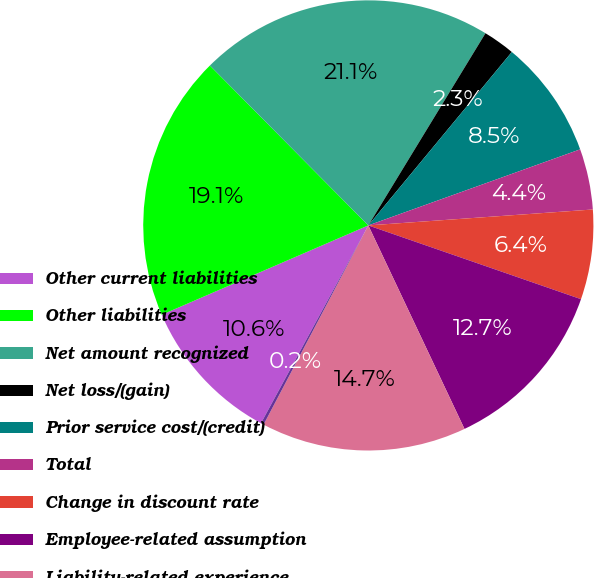Convert chart to OTSL. <chart><loc_0><loc_0><loc_500><loc_500><pie_chart><fcel>Other current liabilities<fcel>Other liabilities<fcel>Net amount recognized<fcel>Net loss/(gain)<fcel>Prior service cost/(credit)<fcel>Total<fcel>Change in discount rate<fcel>Employee-related assumption<fcel>Liability-related experience<fcel>Actual asset return different<nl><fcel>10.59%<fcel>19.07%<fcel>21.14%<fcel>2.29%<fcel>8.51%<fcel>4.36%<fcel>6.44%<fcel>12.66%<fcel>14.73%<fcel>0.21%<nl></chart> 